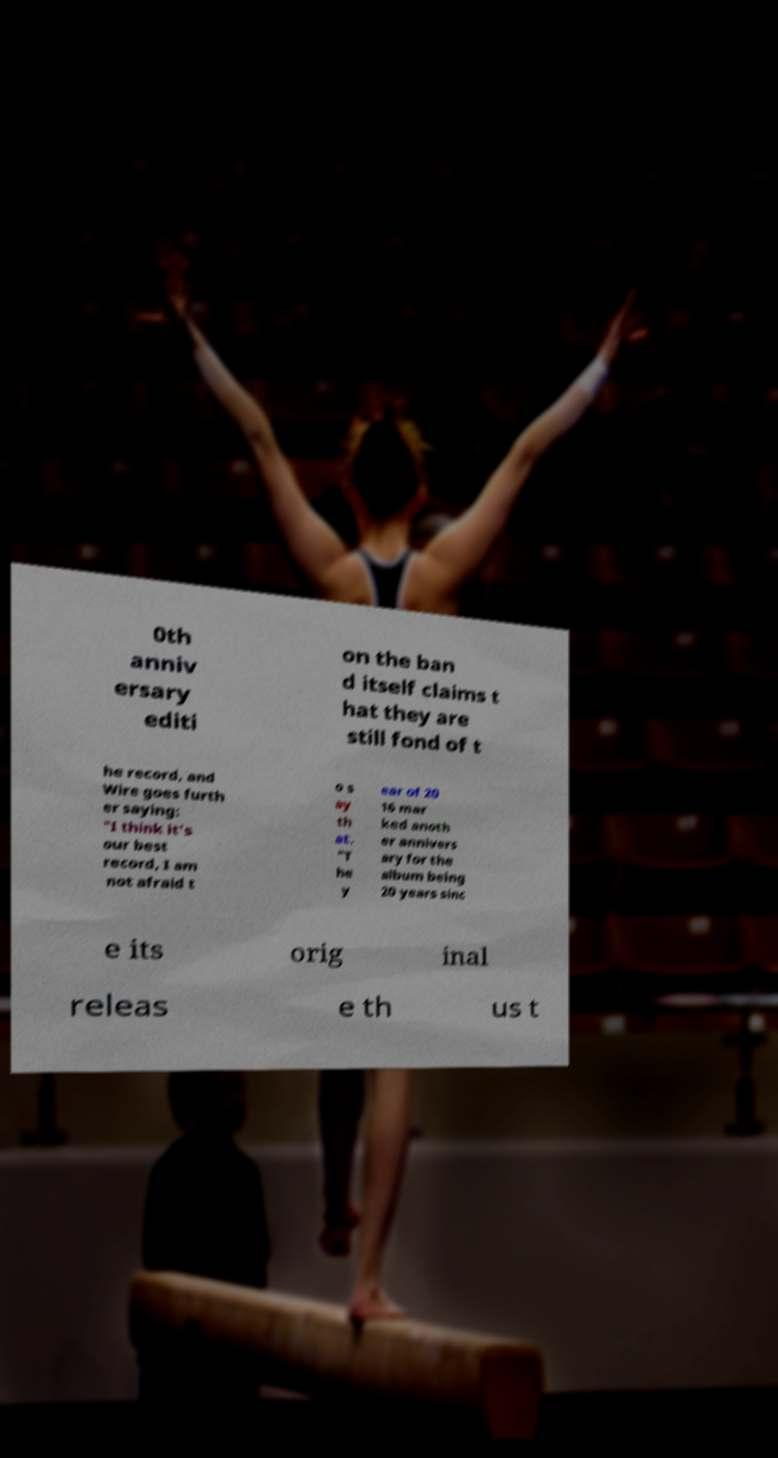Can you read and provide the text displayed in the image?This photo seems to have some interesting text. Can you extract and type it out for me? 0th anniv ersary editi on the ban d itself claims t hat they are still fond of t he record, and Wire goes furth er saying: "I think it's our best record, I am not afraid t o s ay th at. "T he y ear of 20 16 mar ked anoth er annivers ary for the album being 20 years sinc e its orig inal releas e th us t 